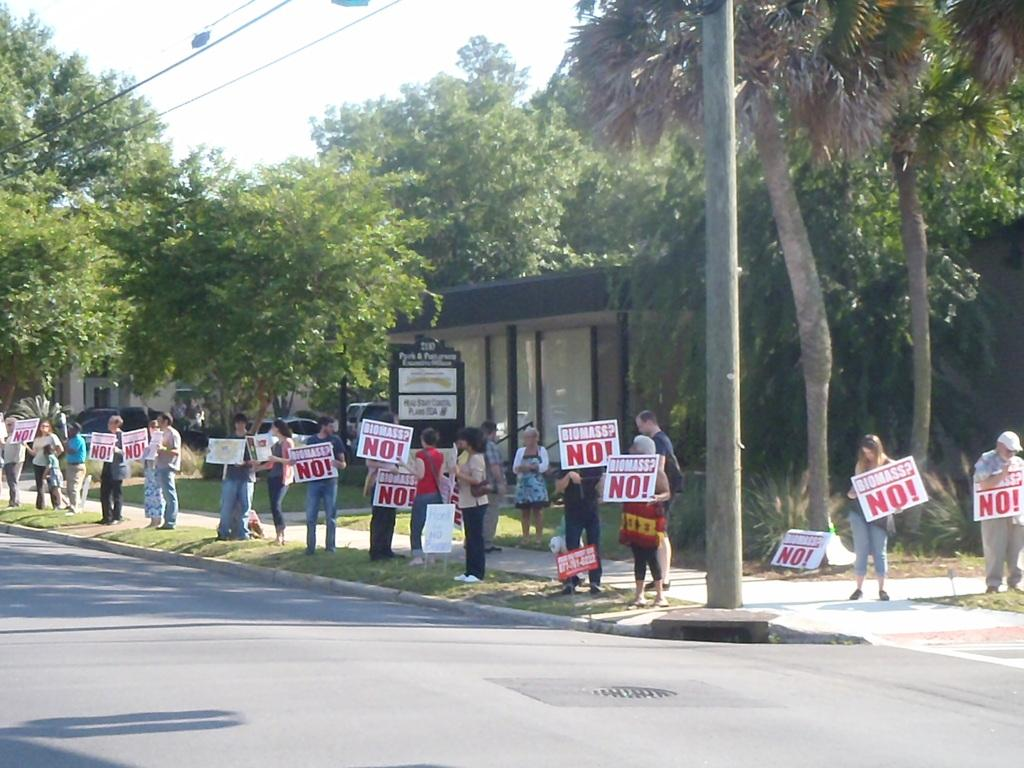<image>
Offer a succinct explanation of the picture presented. A crowd of people holding white signs with red text that say no in bold. 